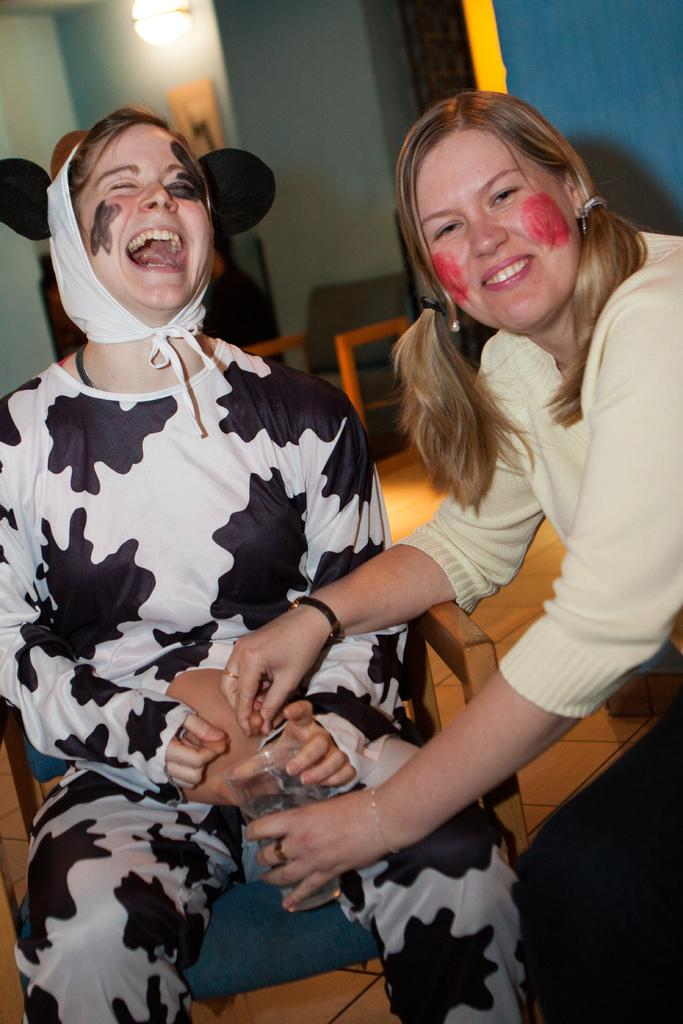How many ladies are present in the image? There are two ladies sitting in the center of the image. What is the lady on the right holding in her hand? The lady on the right is holding a glass in her hand. What can be seen in the background of the image? There are walls, a chair, and a light in the background of the image. Can you see any ice in the image? There is no ice present in the image. How does the lady on the left touch the wall in the image? The lady on the left is not touching the wall in the image. 